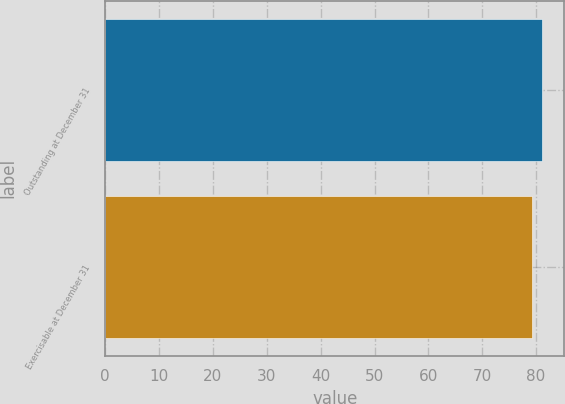Convert chart. <chart><loc_0><loc_0><loc_500><loc_500><bar_chart><fcel>Outstanding at December 31<fcel>Exercisable at December 31<nl><fcel>81.16<fcel>79.33<nl></chart> 